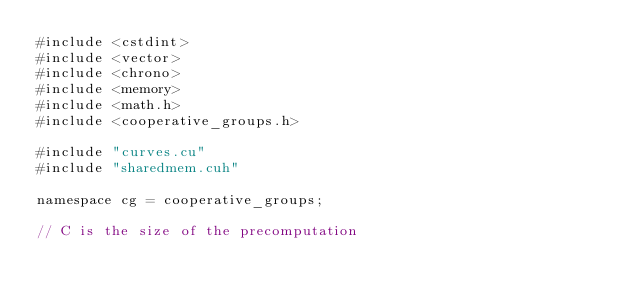<code> <loc_0><loc_0><loc_500><loc_500><_Cuda_>#include <cstdint>
#include <vector>
#include <chrono>
#include <memory>
#include <math.h>
#include <cooperative_groups.h>

#include "curves.cu"
#include "sharedmem.cuh"

namespace cg = cooperative_groups;

// C is the size of the precomputation</code> 